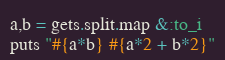Convert code to text. <code><loc_0><loc_0><loc_500><loc_500><_Ruby_>a,b = gets.split.map &:to_i
puts "#{a*b} #{a*2 + b*2}"
</code> 